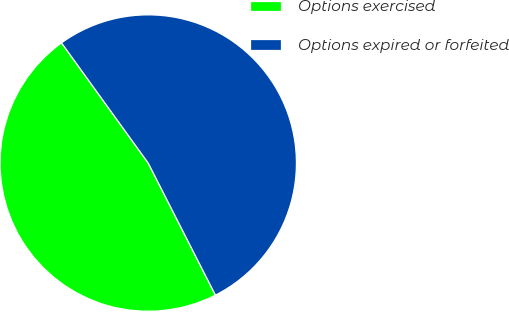Convert chart to OTSL. <chart><loc_0><loc_0><loc_500><loc_500><pie_chart><fcel>Options exercised<fcel>Options expired or forfeited<nl><fcel>47.55%<fcel>52.45%<nl></chart> 